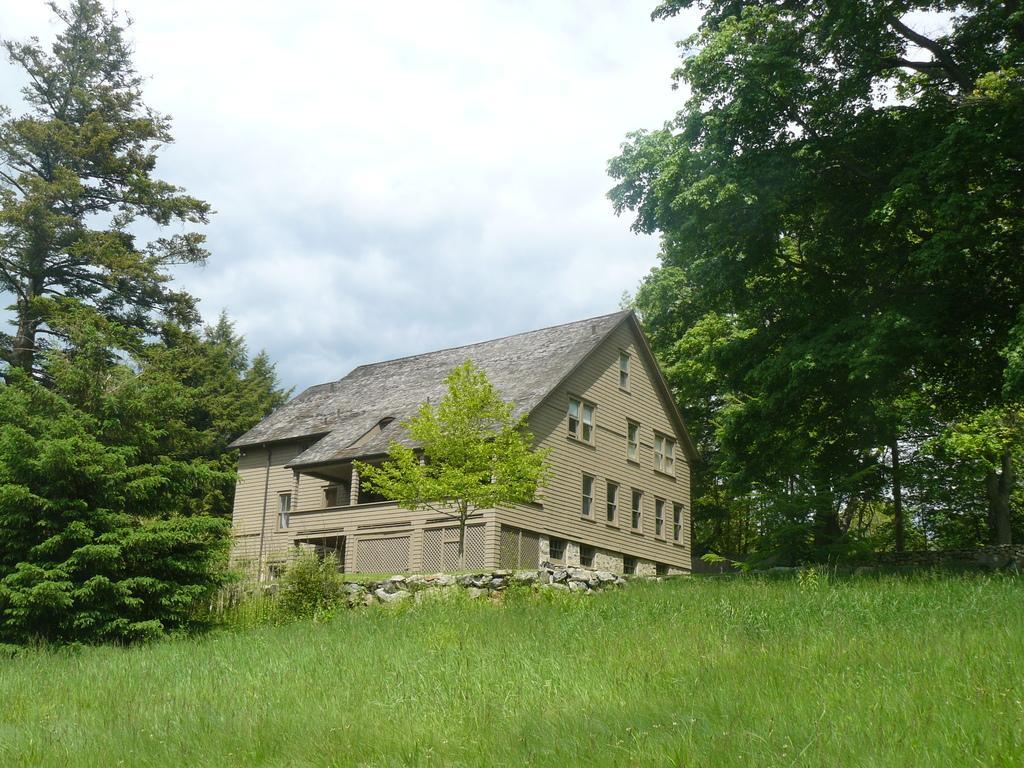Could you give a brief overview of what you see in this image? In this image, we can see a house with windows, pillars and walls. Here we can see so many trees, plants and grass. Background there is sky. 